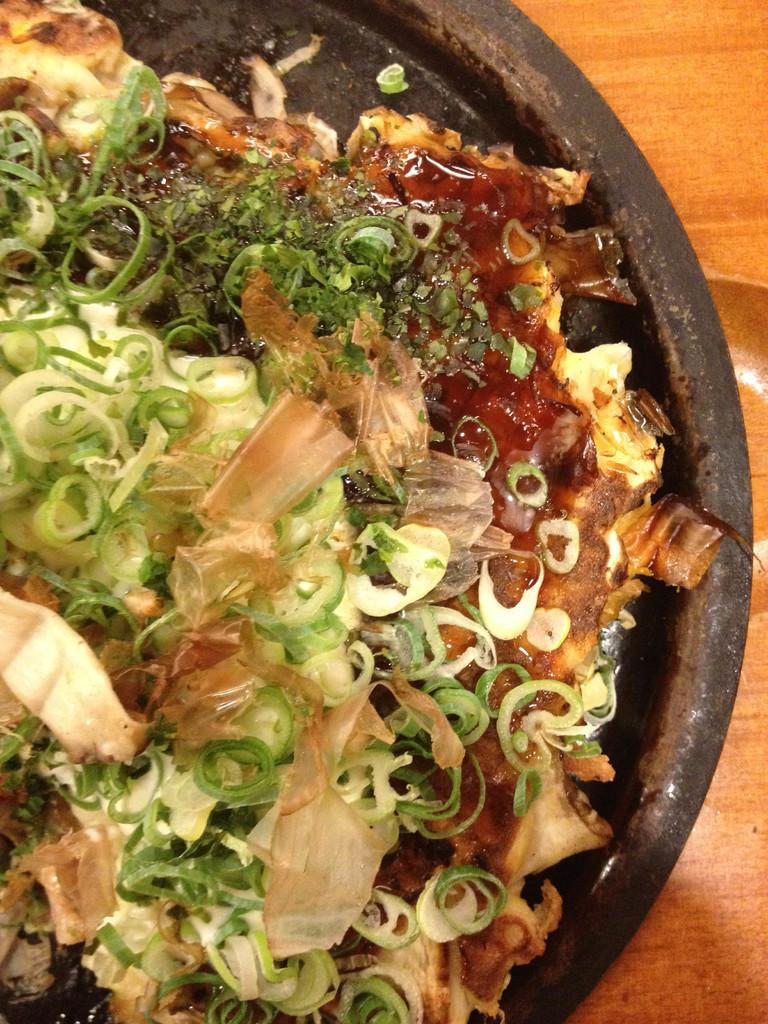What type of surface is visible in the image? There is a wooden surface in the image. What is placed on the wooden surface? There is a pan on the wooden surface. What is inside the pan? There is a food item in the pan. Can you see a squirrel showing a bean in the image? There is no squirrel or bean present in the image. 